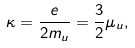<formula> <loc_0><loc_0><loc_500><loc_500>\kappa = \frac { e } { 2 m _ { u } } = \frac { 3 } { 2 } \mu _ { u } ,</formula> 